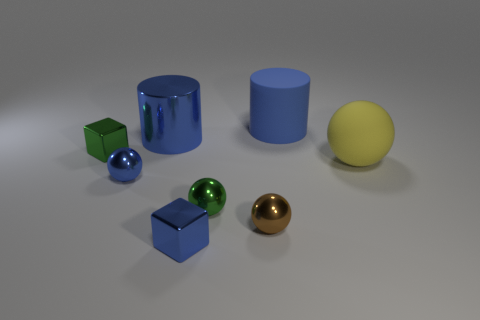Add 2 brown things. How many objects exist? 10 Subtract all cubes. How many objects are left? 6 Subtract 0 gray balls. How many objects are left? 8 Subtract all spheres. Subtract all blue balls. How many objects are left? 3 Add 2 blue blocks. How many blue blocks are left? 3 Add 1 green cubes. How many green cubes exist? 2 